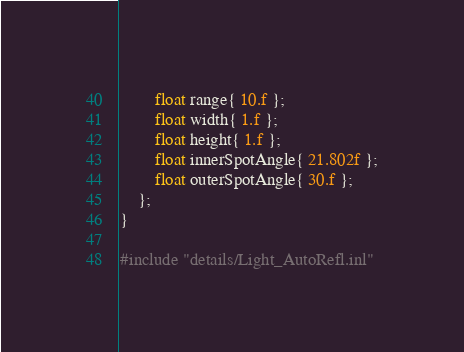<code> <loc_0><loc_0><loc_500><loc_500><_C_>		float range{ 10.f };
		float width{ 1.f };
		float height{ 1.f };
		float innerSpotAngle{ 21.802f };
		float outerSpotAngle{ 30.f };
	};
}

#include "details/Light_AutoRefl.inl"
</code> 